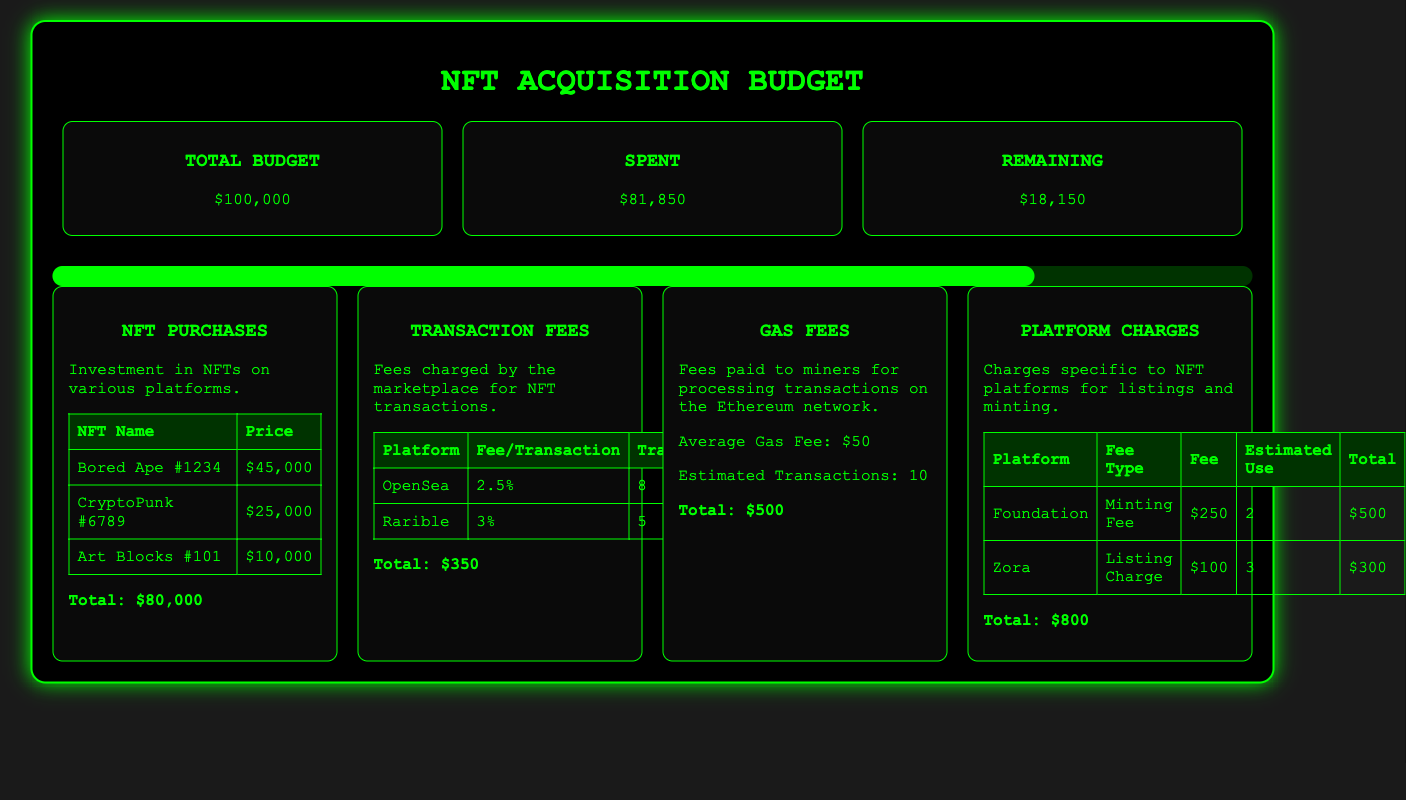What is the total budget? The total budget is clearly stated at the top of the document.
Answer: $100,000 How much has been spent so far? The amount spent is indicated in the budget overview section.
Answer: $81,850 What is the remaining budget? The remaining budget is calculated by subtracting the spent amount from the total budget.
Answer: $18,150 What is the total for NFT purchases? The total for NFT purchases is provided in the breakdown of expenses related to NFTs.
Answer: $80,000 What is the average gas fee? The average gas fee is mentioned under the gas fees section in the document.
Answer: $50 How many transactions were estimated for gas fees? The estimated transactions for gas fees is noted in the gas fees section.
Answer: 10 What is the total of platform charges? The total charges for various platform-specific fees are summed up in the platform charges section.
Answer: $800 Which platform has the highest transaction fee percentage? The platform with the highest transaction fee percentage is found in the transaction fees section.
Answer: Rarible What is the fee per transaction on OpenSea? The fee per transaction for OpenSea is listed in the transaction fees table.
Answer: 2.5% 